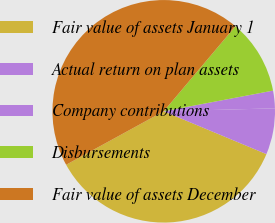<chart> <loc_0><loc_0><loc_500><loc_500><pie_chart><fcel>Fair value of assets January 1<fcel>Actual return on plan assets<fcel>Company contributions<fcel>Disbursements<fcel>Fair value of assets December<nl><fcel>35.74%<fcel>6.71%<fcel>2.55%<fcel>10.87%<fcel>44.13%<nl></chart> 